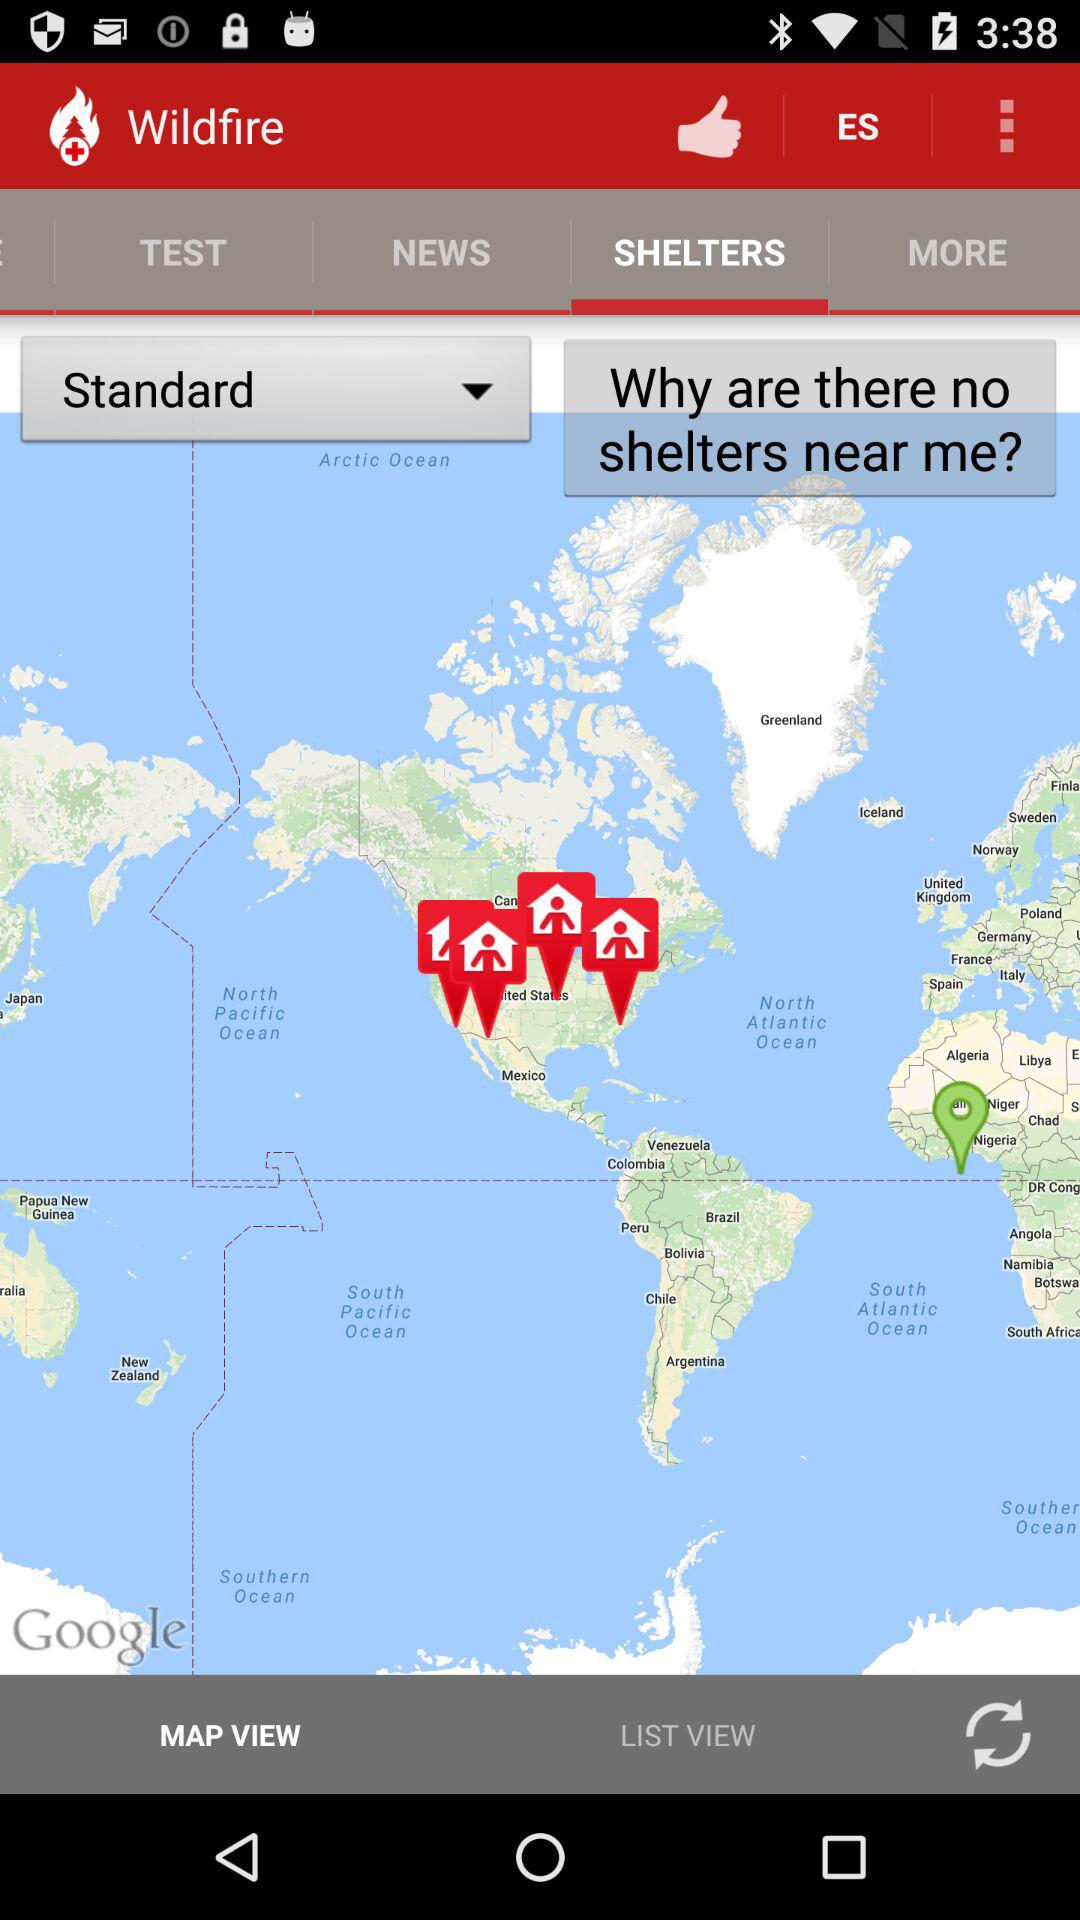Which is the selected tab in Wildfire? The selected tab is "SHELTERS". 